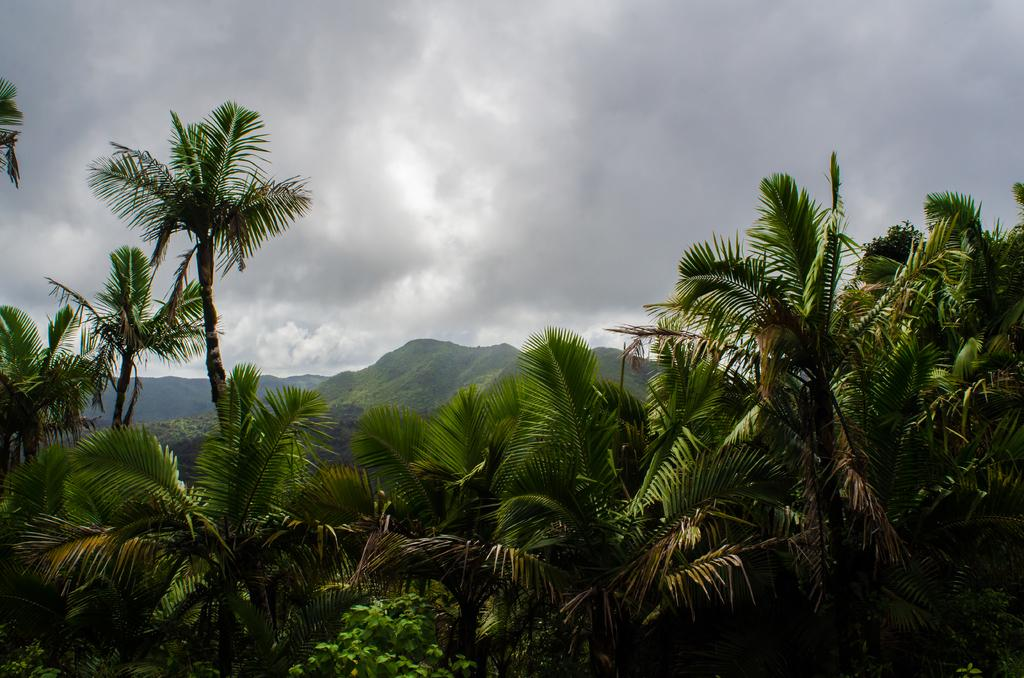What type of landscape feature is at the bottom of the image? There is a hill at the bottom of the image. What type of vegetation can be seen in the image? Trees are visible in the image. What is visible at the top of the image? The sky is visible at the top of the image. What type of wave can be seen crashing on the shore in the image? There is no shore or wave present in the image; it features a hill and trees. What design is visible on the trees in the image? There is no specific design on the trees in the image; they appear to be natural. 